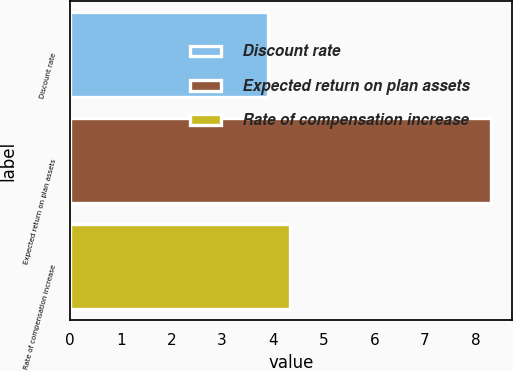Convert chart. <chart><loc_0><loc_0><loc_500><loc_500><bar_chart><fcel>Discount rate<fcel>Expected return on plan assets<fcel>Rate of compensation increase<nl><fcel>3.9<fcel>8.3<fcel>4.34<nl></chart> 